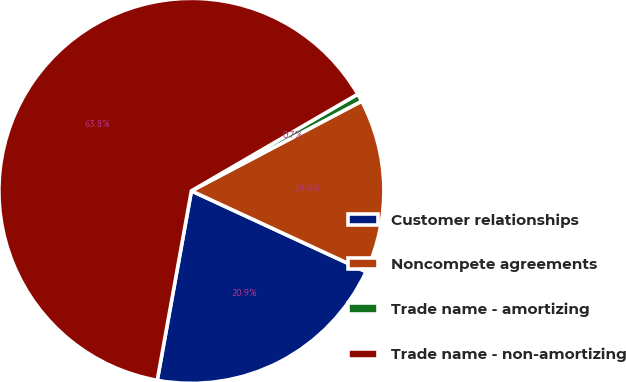Convert chart. <chart><loc_0><loc_0><loc_500><loc_500><pie_chart><fcel>Customer relationships<fcel>Noncompete agreements<fcel>Trade name - amortizing<fcel>Trade name - non-amortizing<nl><fcel>20.94%<fcel>14.62%<fcel>0.66%<fcel>63.78%<nl></chart> 